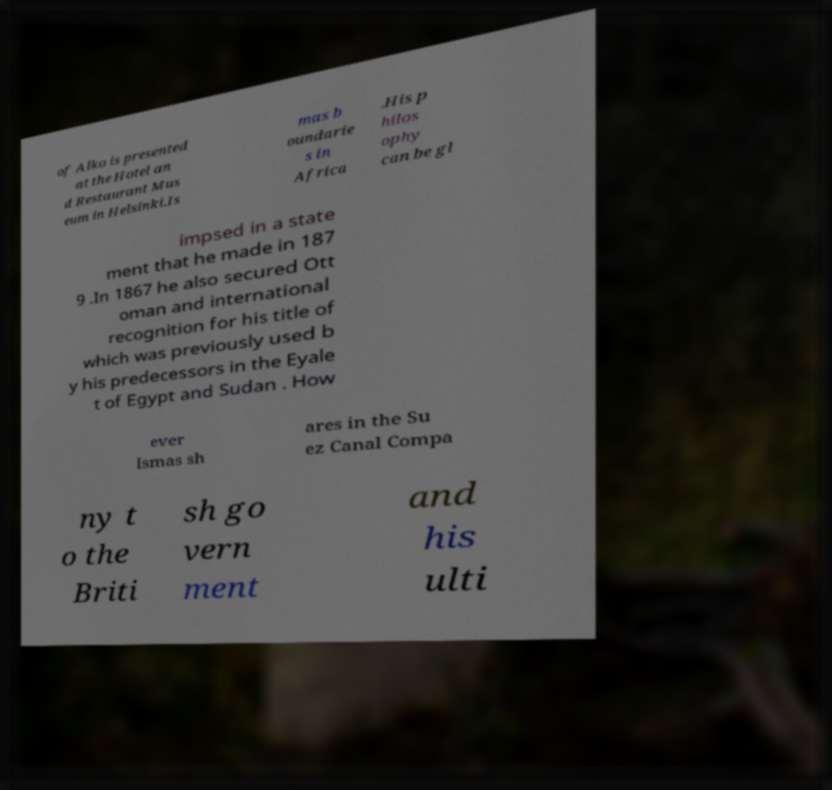For documentation purposes, I need the text within this image transcribed. Could you provide that? of Alko is presented at the Hotel an d Restaurant Mus eum in Helsinki.Is mas b oundarie s in Africa .His p hilos ophy can be gl impsed in a state ment that he made in 187 9 .In 1867 he also secured Ott oman and international recognition for his title of which was previously used b y his predecessors in the Eyale t of Egypt and Sudan . How ever Ismas sh ares in the Su ez Canal Compa ny t o the Briti sh go vern ment and his ulti 